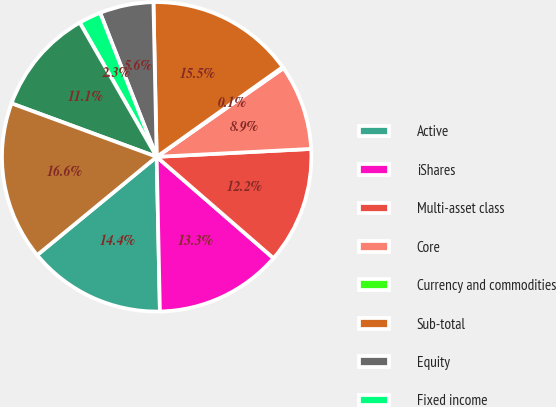Convert chart. <chart><loc_0><loc_0><loc_500><loc_500><pie_chart><fcel>Active<fcel>iShares<fcel>Multi-asset class<fcel>Core<fcel>Currency and commodities<fcel>Sub-total<fcel>Equity<fcel>Fixed income<fcel>Sub-total Non-ETF Index<fcel>Long-term<nl><fcel>14.38%<fcel>13.29%<fcel>12.19%<fcel>8.9%<fcel>0.14%<fcel>15.48%<fcel>5.62%<fcel>2.33%<fcel>11.1%<fcel>16.57%<nl></chart> 